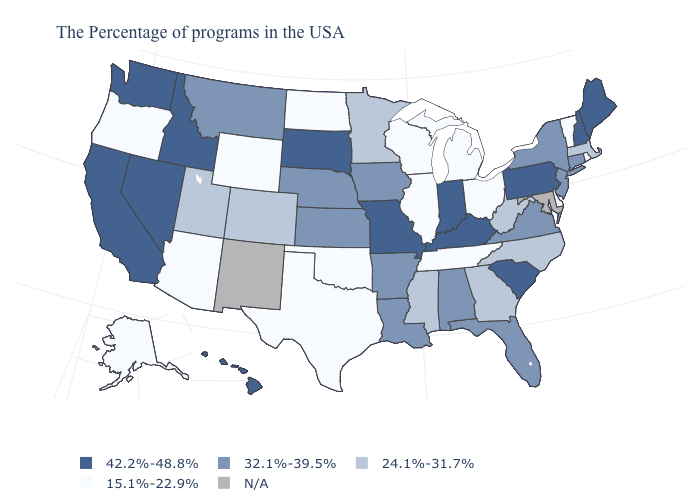What is the value of Hawaii?
Quick response, please. 42.2%-48.8%. What is the value of Connecticut?
Answer briefly. 32.1%-39.5%. What is the value of Colorado?
Write a very short answer. 24.1%-31.7%. Which states have the lowest value in the USA?
Write a very short answer. Rhode Island, Vermont, Delaware, Ohio, Michigan, Tennessee, Wisconsin, Illinois, Oklahoma, Texas, North Dakota, Wyoming, Arizona, Oregon, Alaska. Which states have the lowest value in the USA?
Be succinct. Rhode Island, Vermont, Delaware, Ohio, Michigan, Tennessee, Wisconsin, Illinois, Oklahoma, Texas, North Dakota, Wyoming, Arizona, Oregon, Alaska. Which states hav the highest value in the South?
Concise answer only. South Carolina, Kentucky. Does Idaho have the highest value in the USA?
Be succinct. Yes. How many symbols are there in the legend?
Give a very brief answer. 5. Which states have the lowest value in the West?
Quick response, please. Wyoming, Arizona, Oregon, Alaska. Which states have the lowest value in the USA?
Give a very brief answer. Rhode Island, Vermont, Delaware, Ohio, Michigan, Tennessee, Wisconsin, Illinois, Oklahoma, Texas, North Dakota, Wyoming, Arizona, Oregon, Alaska. Which states have the lowest value in the South?
Give a very brief answer. Delaware, Tennessee, Oklahoma, Texas. Is the legend a continuous bar?
Give a very brief answer. No. What is the value of Rhode Island?
Answer briefly. 15.1%-22.9%. What is the highest value in the USA?
Short answer required. 42.2%-48.8%. What is the value of Wisconsin?
Write a very short answer. 15.1%-22.9%. 